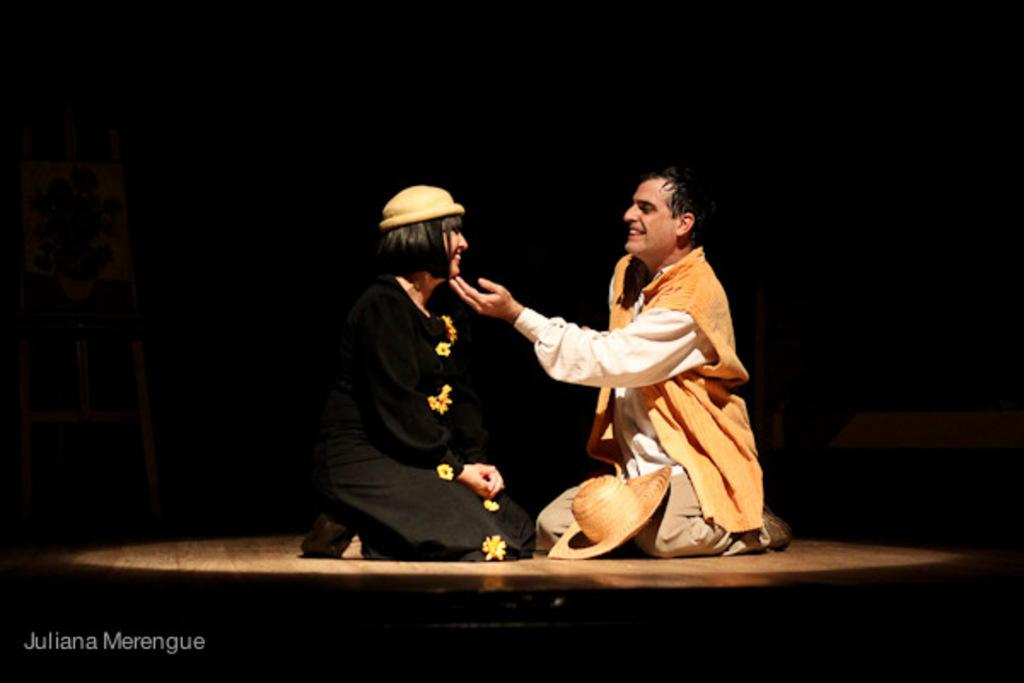Who are the people in the image? There is a guy and a lady in the image. What is the lady wearing on her head? The lady is wearing a cap. Is there any other headwear visible in the image? Yes, there is a hat on the floor in the image. What type of sponge can be seen in the image? There is no sponge present in the image. Who is the representative of the company in the image? The image does not depict a company representative; it simply shows a guy and a lady. 